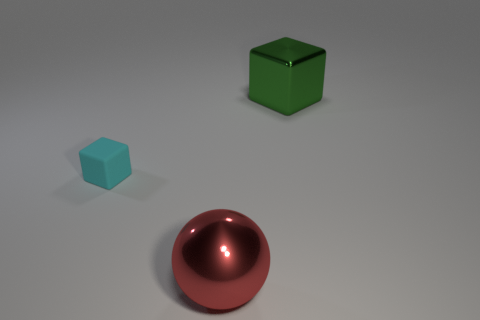Is there anything else that has the same material as the cyan object?
Offer a terse response. No. What number of cyan rubber objects are on the left side of the green metal object?
Provide a succinct answer. 1. Does the large green thing have the same shape as the thing left of the ball?
Provide a short and direct response. Yes. Is there another thing that has the same shape as the green metallic object?
Ensure brevity in your answer.  Yes. There is a big metal object that is in front of the big green metallic cube on the right side of the big red ball; what is its shape?
Your answer should be very brief. Sphere. The metal object that is behind the red sphere has what shape?
Keep it short and to the point. Cube. What number of objects are behind the red thing and on the left side of the large shiny cube?
Keep it short and to the point. 1. There is a block that is made of the same material as the big sphere; what size is it?
Your answer should be very brief. Large. How big is the cyan rubber thing?
Provide a short and direct response. Small. What is the tiny cube made of?
Your response must be concise. Rubber. 